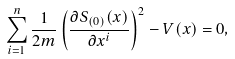Convert formula to latex. <formula><loc_0><loc_0><loc_500><loc_500>\sum _ { i = 1 } ^ { n } \frac { 1 } { 2 m } \left ( \frac { \partial S _ { ( 0 ) } ( x ) } { \partial x ^ { i } } \right ) ^ { 2 } - V ( x ) = 0 ,</formula> 